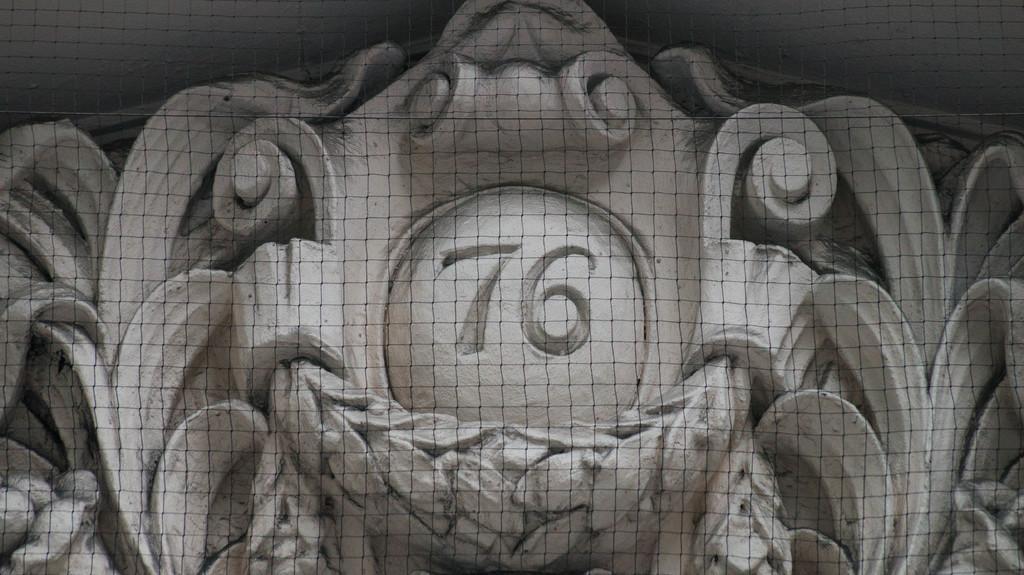Could you give a brief overview of what you see in this image? In this picture I can see there is sculpture and there is a number written on it. There is a fence in front. 